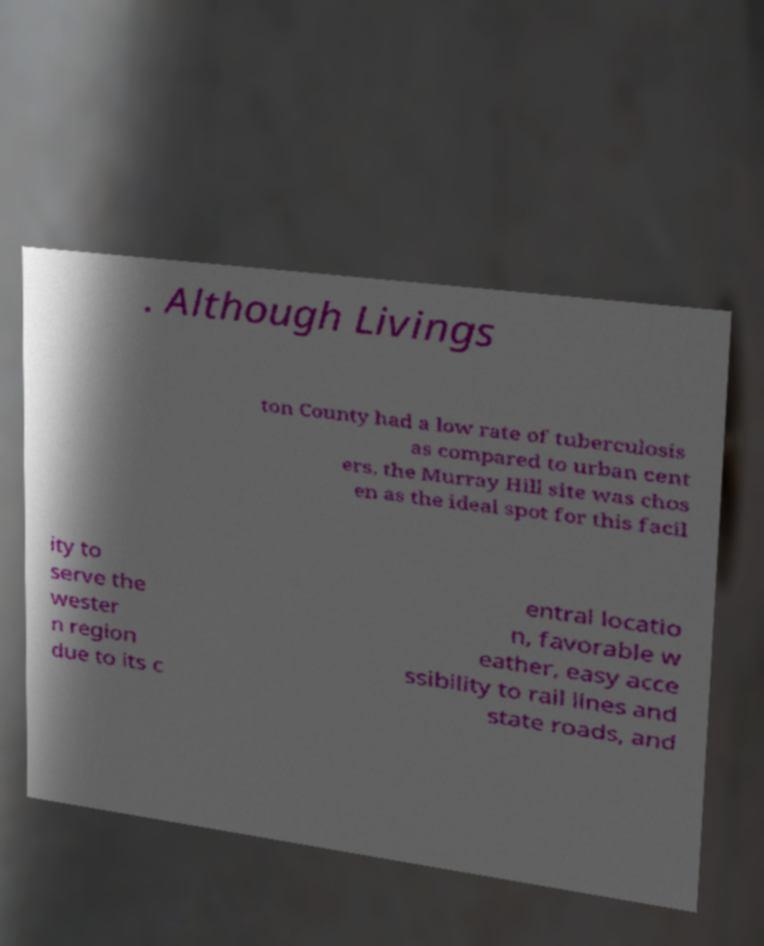What messages or text are displayed in this image? I need them in a readable, typed format. . Although Livings ton County had a low rate of tuberculosis as compared to urban cent ers, the Murray Hill site was chos en as the ideal spot for this facil ity to serve the wester n region due to its c entral locatio n, favorable w eather, easy acce ssibility to rail lines and state roads, and 